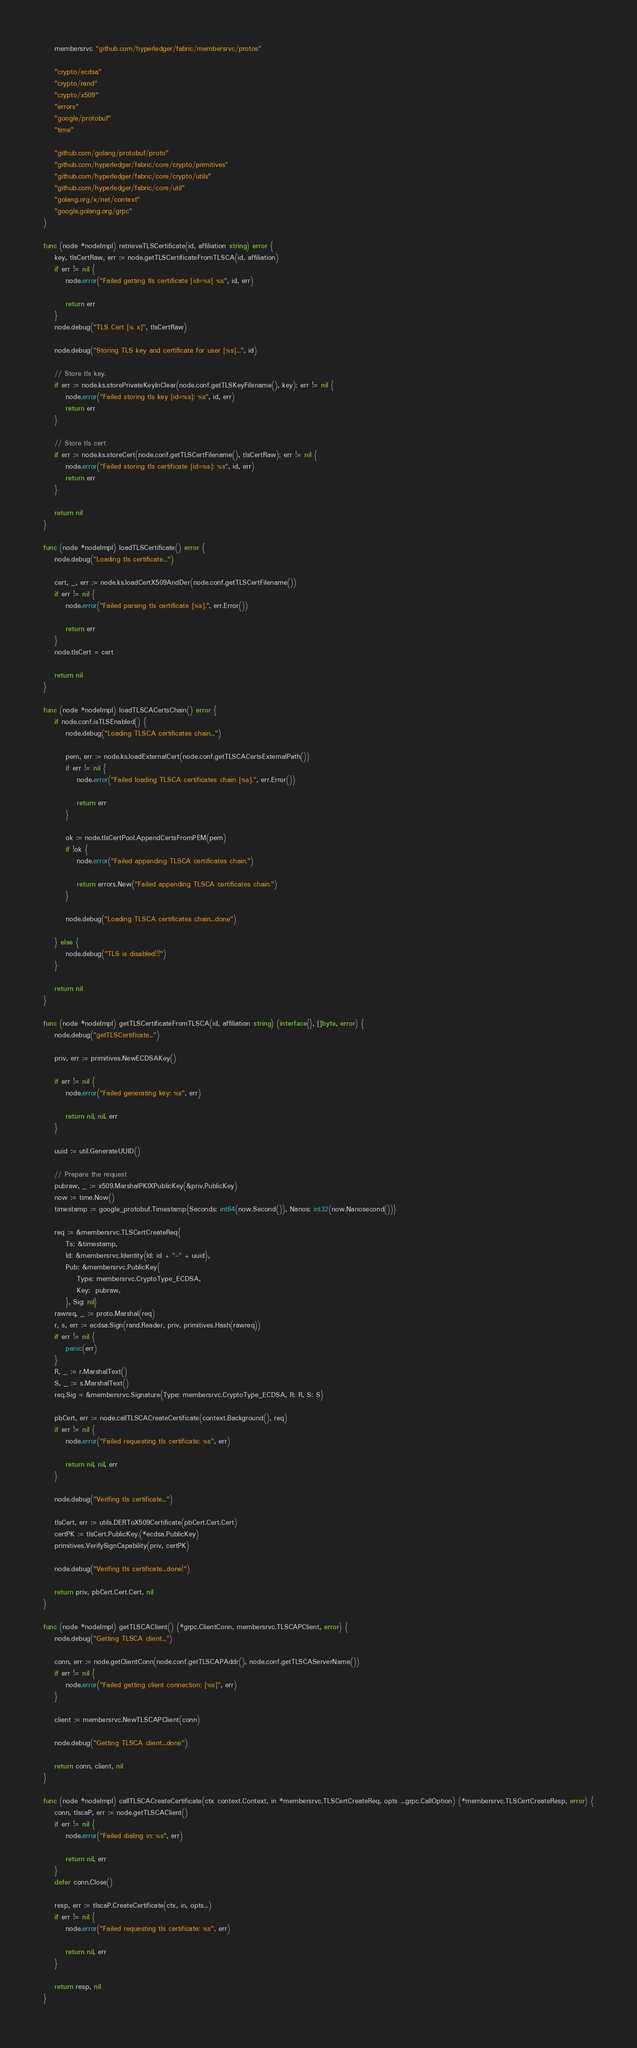<code> <loc_0><loc_0><loc_500><loc_500><_Go_>	membersrvc "github.com/hyperledger/fabric/membersrvc/protos"

	"crypto/ecdsa"
	"crypto/rand"
	"crypto/x509"
	"errors"
	"google/protobuf"
	"time"

	"github.com/golang/protobuf/proto"
	"github.com/hyperledger/fabric/core/crypto/primitives"
	"github.com/hyperledger/fabric/core/crypto/utils"
	"github.com/hyperledger/fabric/core/util"
	"golang.org/x/net/context"
	"google.golang.org/grpc"
)

func (node *nodeImpl) retrieveTLSCertificate(id, affiliation string) error {
	key, tlsCertRaw, err := node.getTLSCertificateFromTLSCA(id, affiliation)
	if err != nil {
		node.error("Failed getting tls certificate [id=%s] %s", id, err)

		return err
	}
	node.debug("TLS Cert [% x]", tlsCertRaw)

	node.debug("Storing TLS key and certificate for user [%s]...", id)

	// Store tls key.
	if err := node.ks.storePrivateKeyInClear(node.conf.getTLSKeyFilename(), key); err != nil {
		node.error("Failed storing tls key [id=%s]: %s", id, err)
		return err
	}

	// Store tls cert
	if err := node.ks.storeCert(node.conf.getTLSCertFilename(), tlsCertRaw); err != nil {
		node.error("Failed storing tls certificate [id=%s]: %s", id, err)
		return err
	}

	return nil
}

func (node *nodeImpl) loadTLSCertificate() error {
	node.debug("Loading tls certificate...")

	cert, _, err := node.ks.loadCertX509AndDer(node.conf.getTLSCertFilename())
	if err != nil {
		node.error("Failed parsing tls certificate [%s].", err.Error())

		return err
	}
	node.tlsCert = cert

	return nil
}

func (node *nodeImpl) loadTLSCACertsChain() error {
	if node.conf.isTLSEnabled() {
		node.debug("Loading TLSCA certificates chain...")

		pem, err := node.ks.loadExternalCert(node.conf.getTLSCACertsExternalPath())
		if err != nil {
			node.error("Failed loading TLSCA certificates chain [%s].", err.Error())

			return err
		}

		ok := node.tlsCertPool.AppendCertsFromPEM(pem)
		if !ok {
			node.error("Failed appending TLSCA certificates chain.")

			return errors.New("Failed appending TLSCA certificates chain.")
		}

		node.debug("Loading TLSCA certificates chain...done")

	} else {
		node.debug("TLS is disabled!!!")
	}

	return nil
}

func (node *nodeImpl) getTLSCertificateFromTLSCA(id, affiliation string) (interface{}, []byte, error) {
	node.debug("getTLSCertificate...")

	priv, err := primitives.NewECDSAKey()

	if err != nil {
		node.error("Failed generating key: %s", err)

		return nil, nil, err
	}

	uuid := util.GenerateUUID()

	// Prepare the request
	pubraw, _ := x509.MarshalPKIXPublicKey(&priv.PublicKey)
	now := time.Now()
	timestamp := google_protobuf.Timestamp{Seconds: int64(now.Second()), Nanos: int32(now.Nanosecond())}

	req := &membersrvc.TLSCertCreateReq{
		Ts: &timestamp,
		Id: &membersrvc.Identity{Id: id + "-" + uuid},
		Pub: &membersrvc.PublicKey{
			Type: membersrvc.CryptoType_ECDSA,
			Key:  pubraw,
		}, Sig: nil}
	rawreq, _ := proto.Marshal(req)
	r, s, err := ecdsa.Sign(rand.Reader, priv, primitives.Hash(rawreq))
	if err != nil {
		panic(err)
	}
	R, _ := r.MarshalText()
	S, _ := s.MarshalText()
	req.Sig = &membersrvc.Signature{Type: membersrvc.CryptoType_ECDSA, R: R, S: S}

	pbCert, err := node.callTLSCACreateCertificate(context.Background(), req)
	if err != nil {
		node.error("Failed requesting tls certificate: %s", err)

		return nil, nil, err
	}

	node.debug("Verifing tls certificate...")

	tlsCert, err := utils.DERToX509Certificate(pbCert.Cert.Cert)
	certPK := tlsCert.PublicKey.(*ecdsa.PublicKey)
	primitives.VerifySignCapability(priv, certPK)

	node.debug("Verifing tls certificate...done!")

	return priv, pbCert.Cert.Cert, nil
}

func (node *nodeImpl) getTLSCAClient() (*grpc.ClientConn, membersrvc.TLSCAPClient, error) {
	node.debug("Getting TLSCA client...")

	conn, err := node.getClientConn(node.conf.getTLSCAPAddr(), node.conf.getTLSCAServerName())
	if err != nil {
		node.error("Failed getting client connection: [%s]", err)
	}

	client := membersrvc.NewTLSCAPClient(conn)

	node.debug("Getting TLSCA client...done")

	return conn, client, nil
}

func (node *nodeImpl) callTLSCACreateCertificate(ctx context.Context, in *membersrvc.TLSCertCreateReq, opts ...grpc.CallOption) (*membersrvc.TLSCertCreateResp, error) {
	conn, tlscaP, err := node.getTLSCAClient()
	if err != nil {
		node.error("Failed dialing in: %s", err)

		return nil, err
	}
	defer conn.Close()

	resp, err := tlscaP.CreateCertificate(ctx, in, opts...)
	if err != nil {
		node.error("Failed requesting tls certificate: %s", err)

		return nil, err
	}

	return resp, nil
}
</code> 